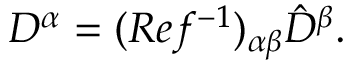<formula> <loc_0><loc_0><loc_500><loc_500>D ^ { \alpha } = ( R e f ^ { - 1 } ) _ { \alpha \beta } \hat { D } ^ { \beta } .</formula> 